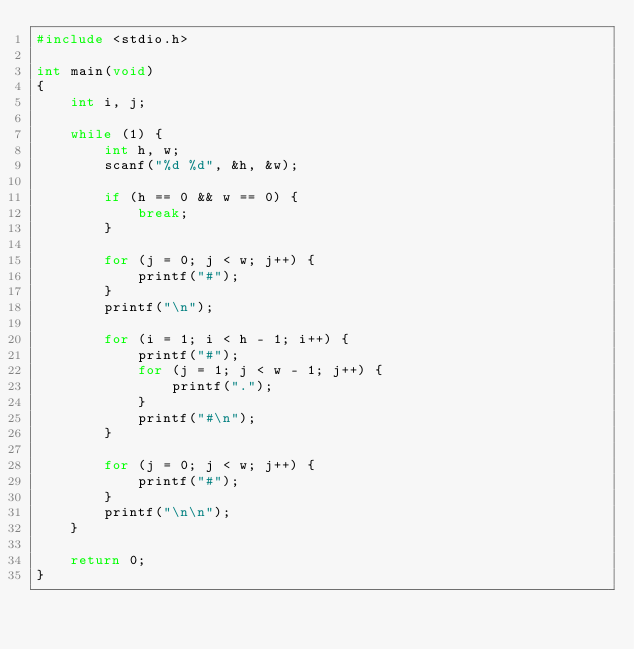<code> <loc_0><loc_0><loc_500><loc_500><_C_>#include <stdio.h>

int main(void)
{
    int i, j;

    while (1) {
        int h, w;
        scanf("%d %d", &h, &w);

        if (h == 0 && w == 0) {
            break;
        }

        for (j = 0; j < w; j++) {
            printf("#");
        }
        printf("\n");

        for (i = 1; i < h - 1; i++) {
            printf("#");
            for (j = 1; j < w - 1; j++) {
                printf(".");
            }
            printf("#\n");
        }

        for (j = 0; j < w; j++) {
            printf("#");
        }
        printf("\n\n");
    }

    return 0;
}</code> 